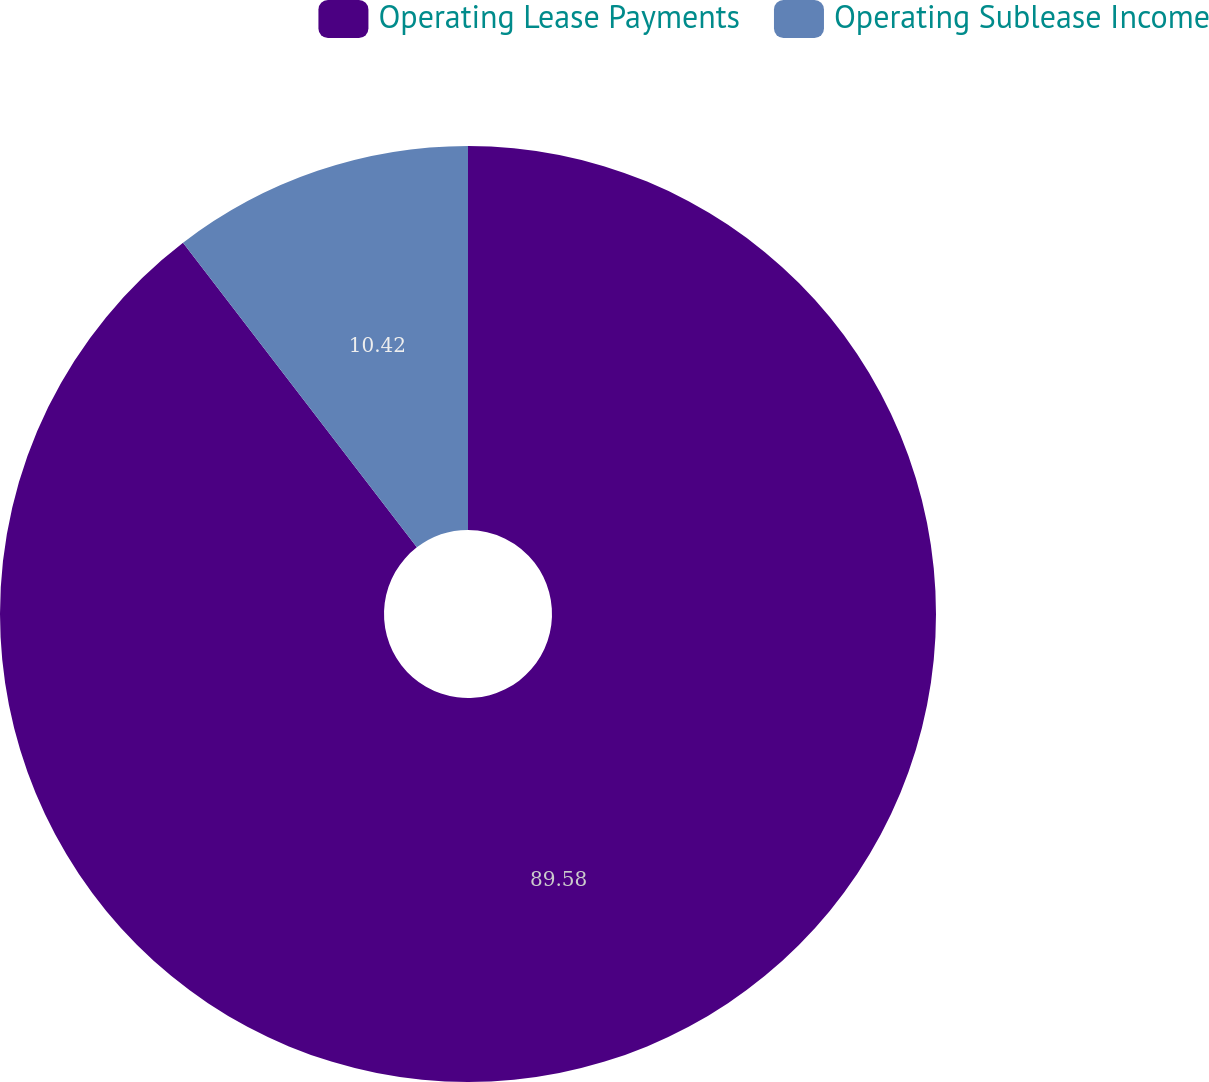<chart> <loc_0><loc_0><loc_500><loc_500><pie_chart><fcel>Operating Lease Payments<fcel>Operating Sublease Income<nl><fcel>89.58%<fcel>10.42%<nl></chart> 